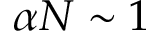Convert formula to latex. <formula><loc_0><loc_0><loc_500><loc_500>\alpha N \sim 1</formula> 